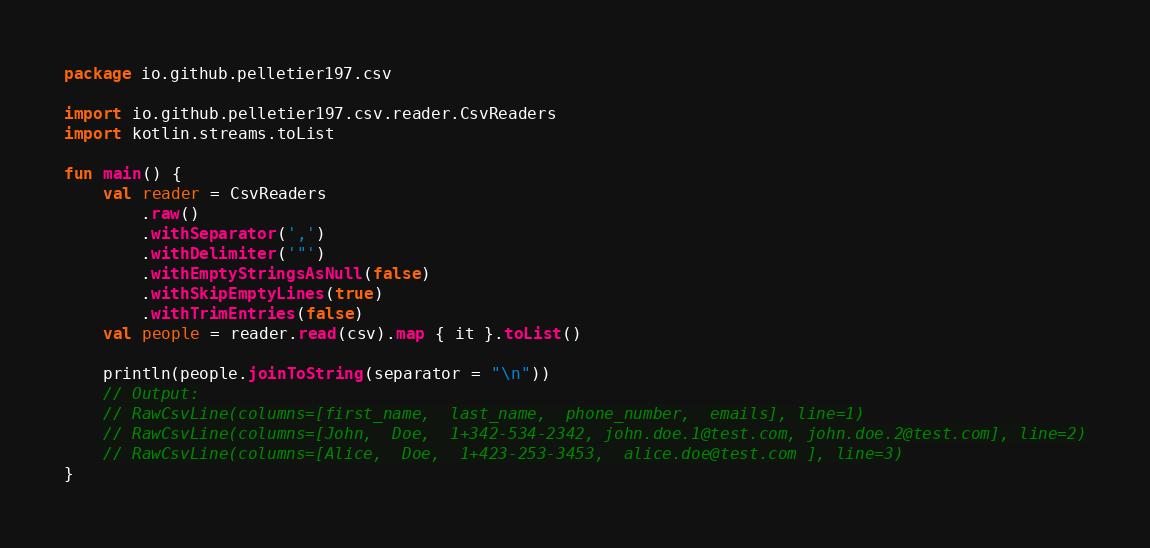<code> <loc_0><loc_0><loc_500><loc_500><_Kotlin_>package io.github.pelletier197.csv

import io.github.pelletier197.csv.reader.CsvReaders
import kotlin.streams.toList

fun main() {
    val reader = CsvReaders
        .raw()
        .withSeparator(',')
        .withDelimiter('"')
        .withEmptyStringsAsNull(false)
        .withSkipEmptyLines(true)
        .withTrimEntries(false)
    val people = reader.read(csv).map { it }.toList()

    println(people.joinToString(separator = "\n"))
    // Output:
    // RawCsvLine(columns=[first_name,  last_name,  phone_number,  emails], line=1)
    // RawCsvLine(columns=[John,  Doe,  1+342-534-2342, john.doe.1@test.com, john.doe.2@test.com], line=2)
    // RawCsvLine(columns=[Alice,  Doe,  1+423-253-3453,  alice.doe@test.com ], line=3)
}
</code> 